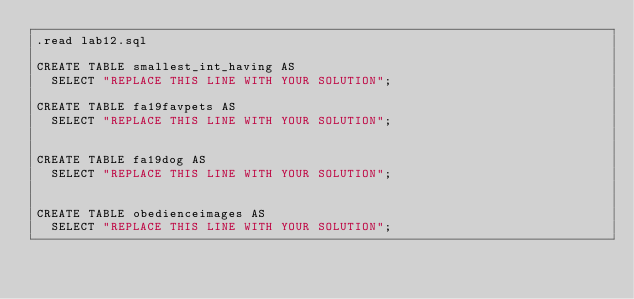<code> <loc_0><loc_0><loc_500><loc_500><_SQL_>.read lab12.sql

CREATE TABLE smallest_int_having AS
  SELECT "REPLACE THIS LINE WITH YOUR SOLUTION";

CREATE TABLE fa19favpets AS
  SELECT "REPLACE THIS LINE WITH YOUR SOLUTION";


CREATE TABLE fa19dog AS
  SELECT "REPLACE THIS LINE WITH YOUR SOLUTION";


CREATE TABLE obedienceimages AS
  SELECT "REPLACE THIS LINE WITH YOUR SOLUTION";
</code> 